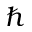Convert formula to latex. <formula><loc_0><loc_0><loc_500><loc_500>\hbar</formula> 